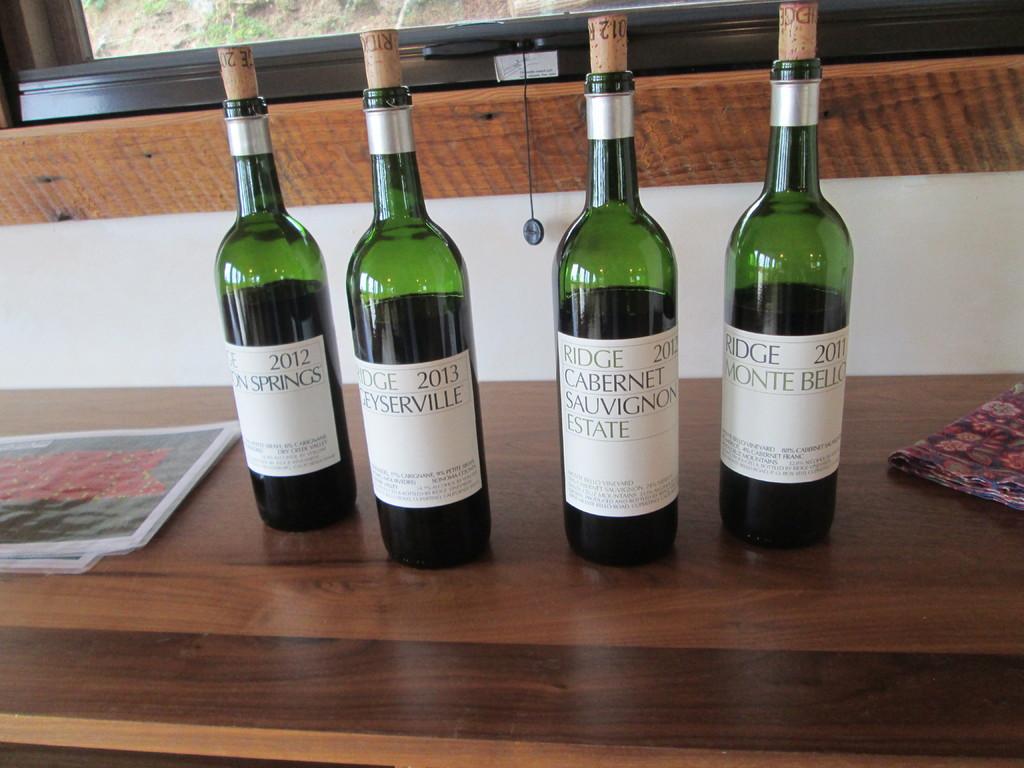What is the year on the left most bottle?
Ensure brevity in your answer.  2012. What "estate" is the one bottle from?
Ensure brevity in your answer.  Ridge. 